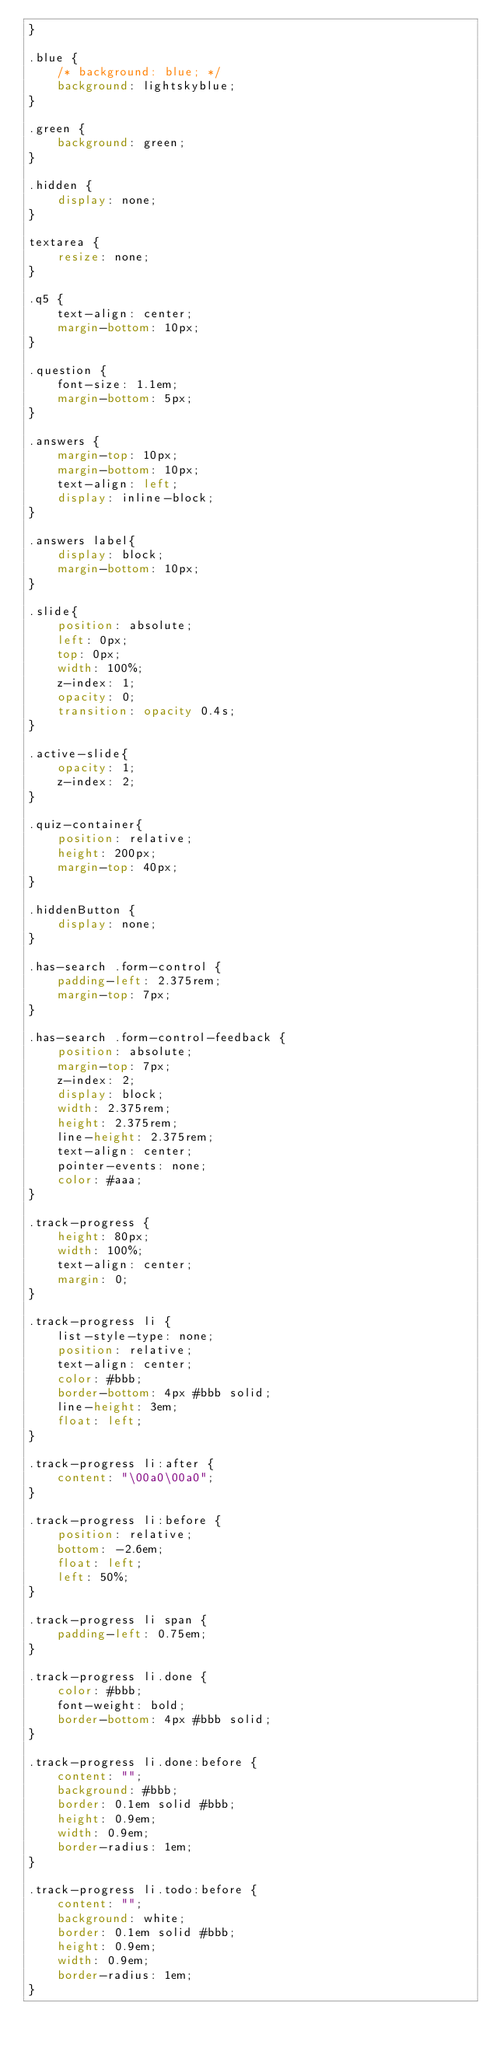<code> <loc_0><loc_0><loc_500><loc_500><_CSS_>}

.blue {
    /* background: blue; */
    background: lightskyblue;
}

.green {
    background: green;
}

.hidden {
    display: none;
}

textarea {
    resize: none;
}

.q5 {
    text-align: center;
    margin-bottom: 10px;
}

.question {
    font-size: 1.1em;
    margin-bottom: 5px;
}

.answers {
    margin-top: 10px;
    margin-bottom: 10px;
    text-align: left;
    display: inline-block;
}

.answers label{
    display: block;
    margin-bottom: 10px;
}

.slide{
    position: absolute;
    left: 0px;
    top: 0px;
    width: 100%;
    z-index: 1;
    opacity: 0;
    transition: opacity 0.4s;
}

.active-slide{
    opacity: 1;
    z-index: 2;
}

.quiz-container{
    position: relative;
    height: 200px;
    margin-top: 40px;
}

.hiddenButton {
    display: none;
}

.has-search .form-control {
    padding-left: 2.375rem;
    margin-top: 7px;
}

.has-search .form-control-feedback {
    position: absolute;
    margin-top: 7px;
    z-index: 2;
    display: block;
    width: 2.375rem;
    height: 2.375rem;
    line-height: 2.375rem;
    text-align: center;
    pointer-events: none;
    color: #aaa;
}

.track-progress {
    height: 80px;
    width: 100%;
    text-align: center;
    margin: 0;
}
    
.track-progress li {
    list-style-type: none;
    position: relative;
    text-align: center;
    color: #bbb;
    border-bottom: 4px #bbb solid;
    line-height: 3em;
    float: left;
}
      
.track-progress li:after {
    content: "\00a0\00a0";
}
      
.track-progress li:before {
    position: relative;
    bottom: -2.6em;
    float: left;
    left: 50%;
}
      
.track-progress li span {
    padding-left: 0.75em;
}
    
.track-progress li.done {
    color: #bbb;
    font-weight: bold;
    border-bottom: 4px #bbb solid;
}
      
.track-progress li.done:before {
    content: "";
    background: #bbb;
    border: 0.1em solid #bbb;
    height: 0.9em;
    width: 0.9em;
    border-radius: 1em;
}
    
.track-progress li.todo:before {
    content: "";
    background: white;
    border: 0.1em solid #bbb;
    height: 0.9em;
    width: 0.9em;
    border-radius: 1em;
}
  </code> 